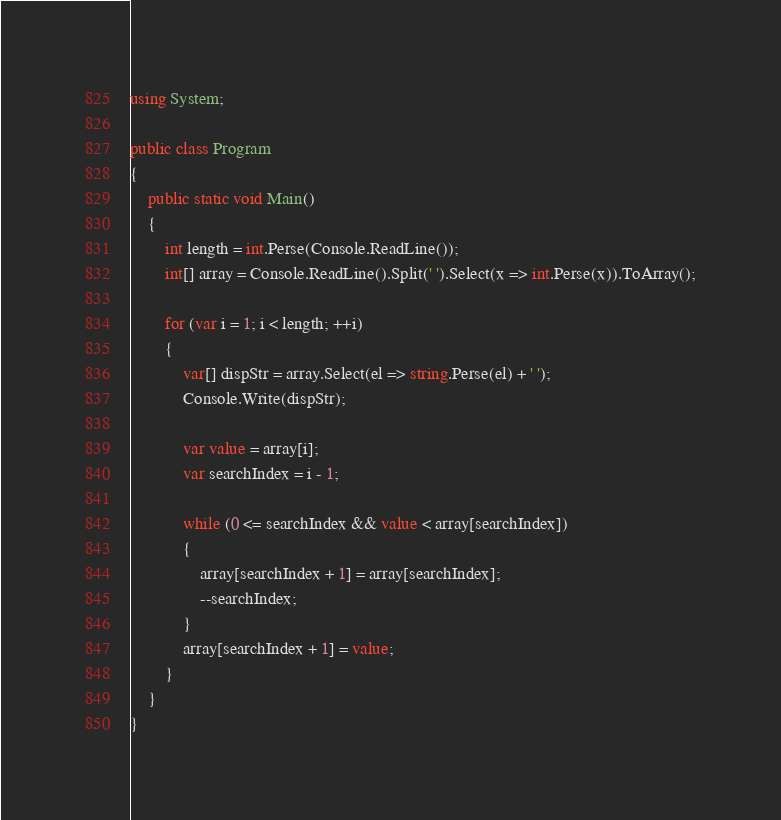<code> <loc_0><loc_0><loc_500><loc_500><_C#_>using System;

public class Program
{
    public static void Main()
    {
        int length = int.Perse(Console.ReadLine());
        int[] array = Console.ReadLine().Split(' ').Select(x => int.Perse(x)).ToArray();
        
        for (var i = 1; i < length; ++i)
        {
            var[] dispStr = array.Select(el => string.Perse(el) + ' ');
            Console.Write(dispStr);
            
            var value = array[i];
            var searchIndex = i - 1;
            
            while (0 <= searchIndex && value < array[searchIndex])
            {
                array[searchIndex + 1] = array[searchIndex];
                --searchIndex;
            }
            array[searchIndex + 1] = value;
        }
    }
}
</code> 